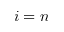Convert formula to latex. <formula><loc_0><loc_0><loc_500><loc_500>i = n</formula> 